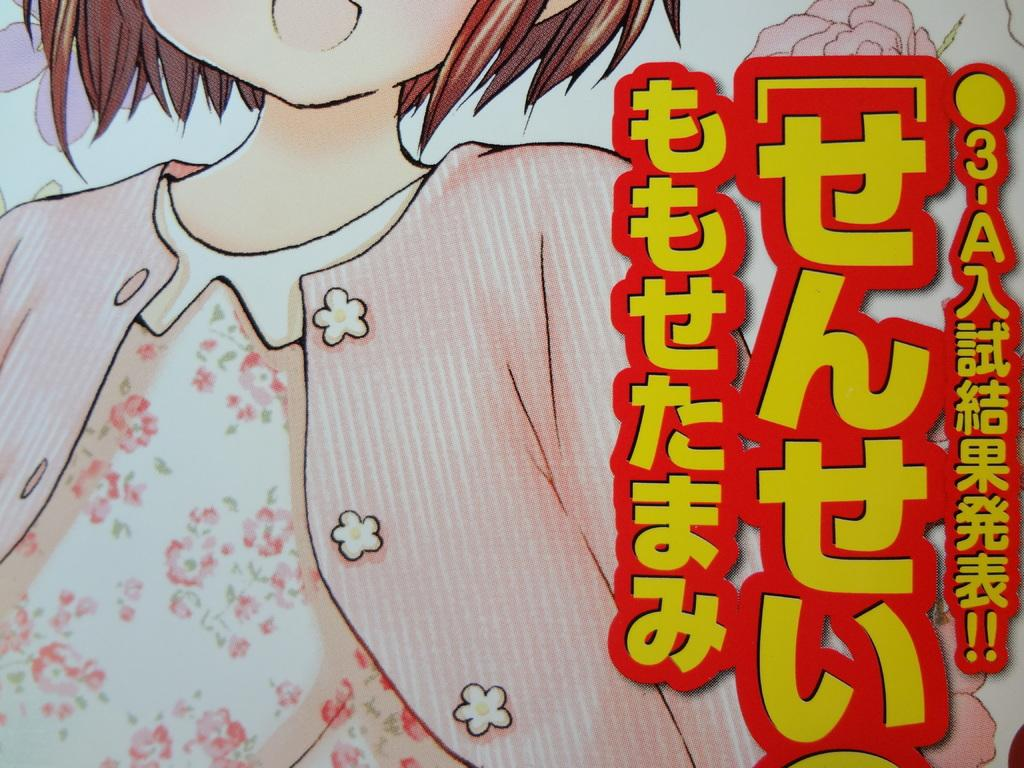What is the main subject of the image? There is a depiction of a person in the image. Can you describe any additional elements in the image? Yes, there is some text in the image. How many ducks are swimming in the water near the person in the image? There are no ducks present in the image. What type of spade is being used by the person in the image? There is no spade visible in the image. 